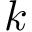Convert formula to latex. <formula><loc_0><loc_0><loc_500><loc_500>k</formula> 